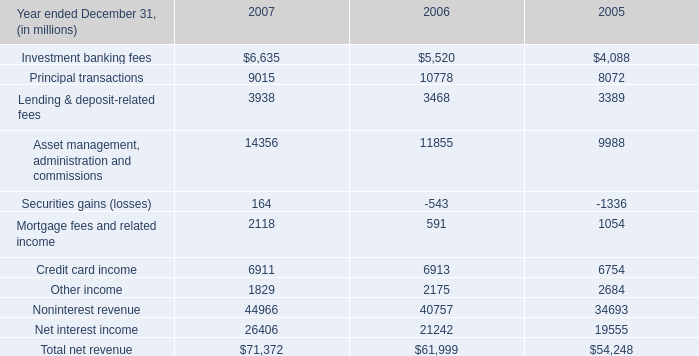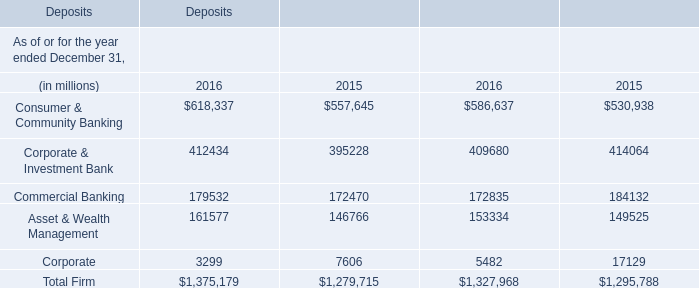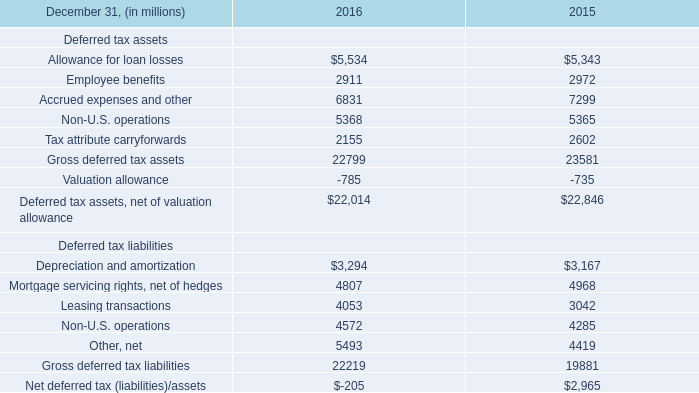In the year with largest amount of Asset & Wealth Management, what's the increasing rate of Commercial Banking? 
Computations: ((179532 - 172470) / 179532)
Answer: 0.03934. 